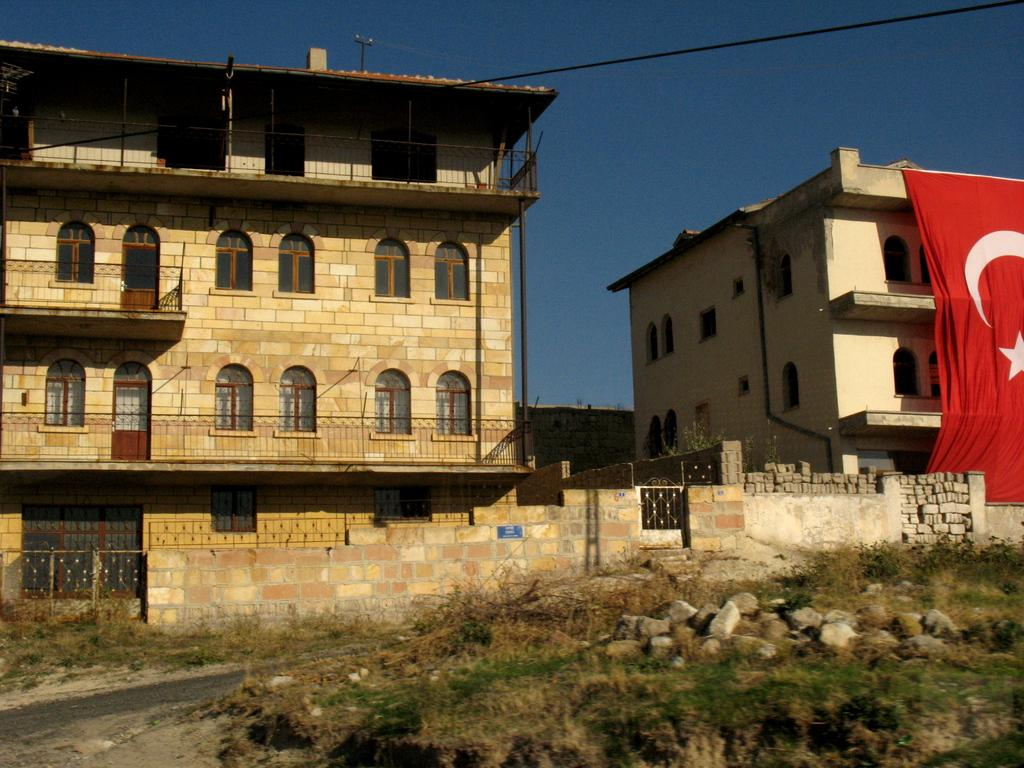What can be seen in the background of the image? There are buildings in the background of the image. Where is the flag located in the image? The flag is on the left side of the image. What is present on the land in the foreground of the image? There are rocks on the land in the foreground of the image. What is visible above the land in the image? The sky is visible above the land. What type of hobbies does the porter engage in while wearing the apparel in the image? There is no porter or apparel present in the image. What type of clothing is the person wearing in the image? There is no person or clothing visible in the image. 